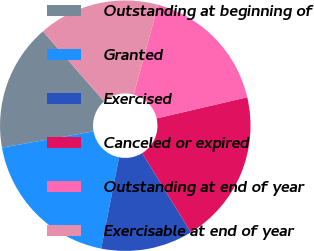<chart> <loc_0><loc_0><loc_500><loc_500><pie_chart><fcel>Outstanding at beginning of<fcel>Granted<fcel>Exercised<fcel>Canceled or expired<fcel>Outstanding at end of year<fcel>Exercisable at end of year<nl><fcel>16.39%<fcel>19.12%<fcel>11.86%<fcel>19.87%<fcel>17.14%<fcel>15.64%<nl></chart> 